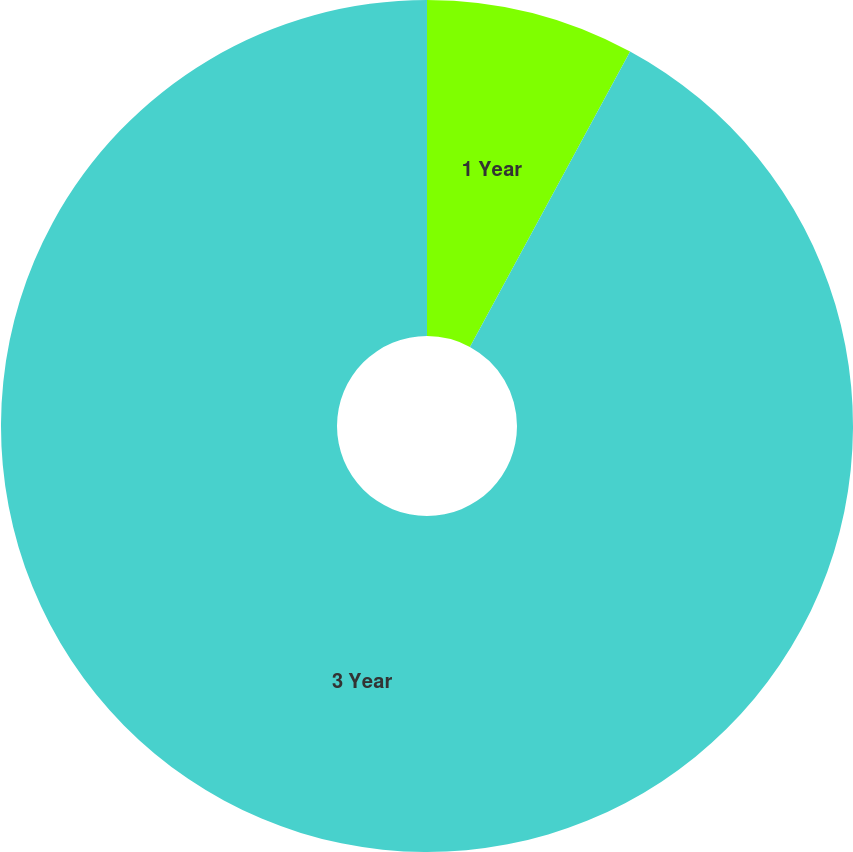Convert chart to OTSL. <chart><loc_0><loc_0><loc_500><loc_500><pie_chart><fcel>1 Year<fcel>3 Year<nl><fcel>7.91%<fcel>92.09%<nl></chart> 